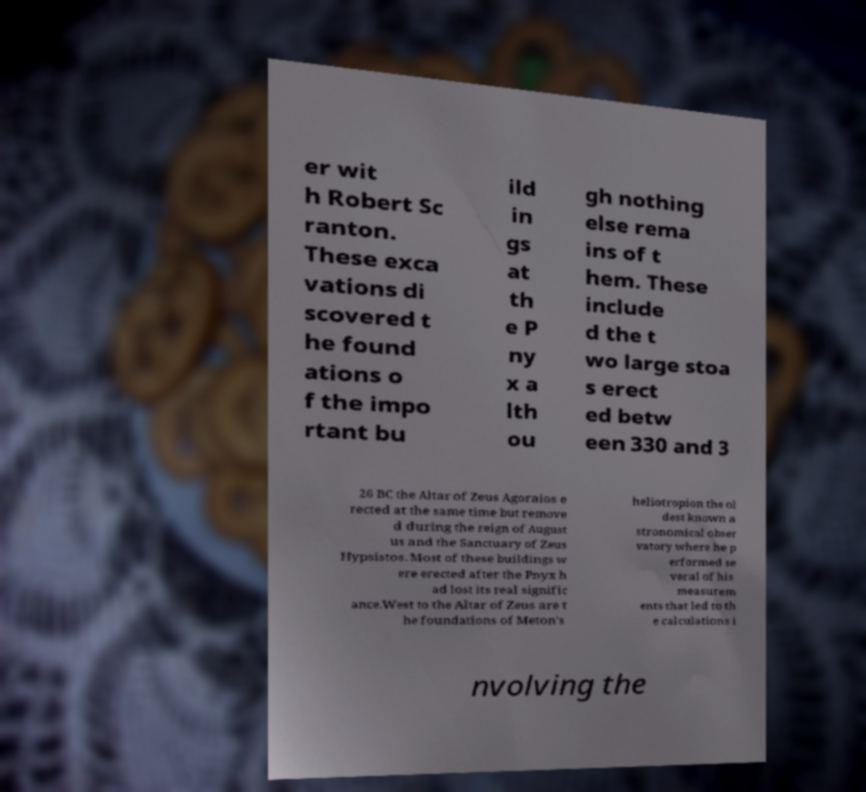For documentation purposes, I need the text within this image transcribed. Could you provide that? er wit h Robert Sc ranton. These exca vations di scovered t he found ations o f the impo rtant bu ild in gs at th e P ny x a lth ou gh nothing else rema ins of t hem. These include d the t wo large stoa s erect ed betw een 330 and 3 26 BC the Altar of Zeus Agoraios e rected at the same time but remove d during the reign of August us and the Sanctuary of Zeus Hypsistos. Most of these buildings w ere erected after the Pnyx h ad lost its real signific ance.West to the Altar of Zeus are t he foundations of Meton's heliotropion the ol dest known a stronomical obser vatory where he p erformed se veral of his measurem ents that led to th e calculations i nvolving the 